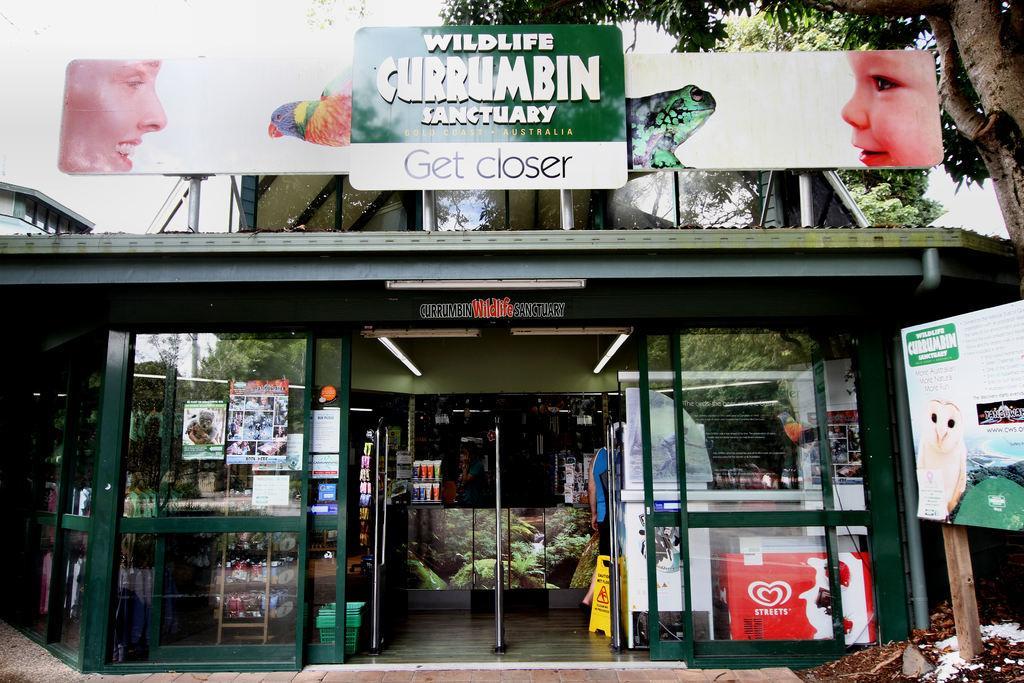In one or two sentences, can you explain what this image depicts? In this picture it looks like a store in the middle, I can see a person, on the left side there is a board with text and pictures on it. At the top there is a hoarding, in the background there are trees. 